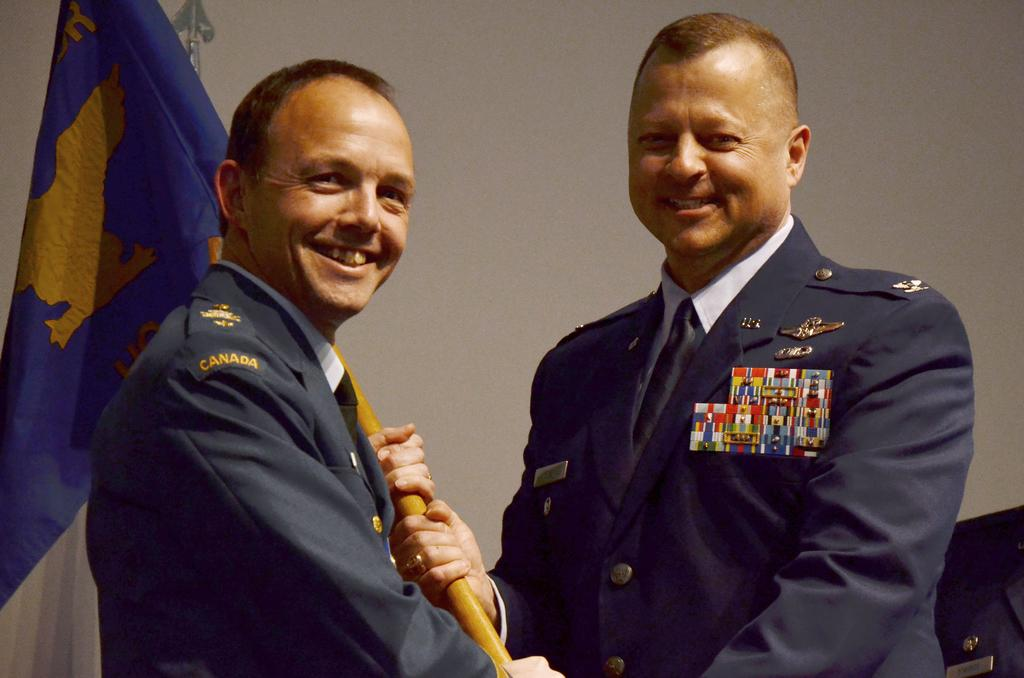How many people are in the image? There are two people in the image. What are the two people doing in the image? The two people are holding a flag. What can be seen in the background of the image? There is a wall in the background of the image. What is located in the bottom right corner of the image? There is an object in the bottom right corner of the image. What letter is written on the flag in the image? There is no letter written on the flag in the image; it is not mentioned in the provided facts. 